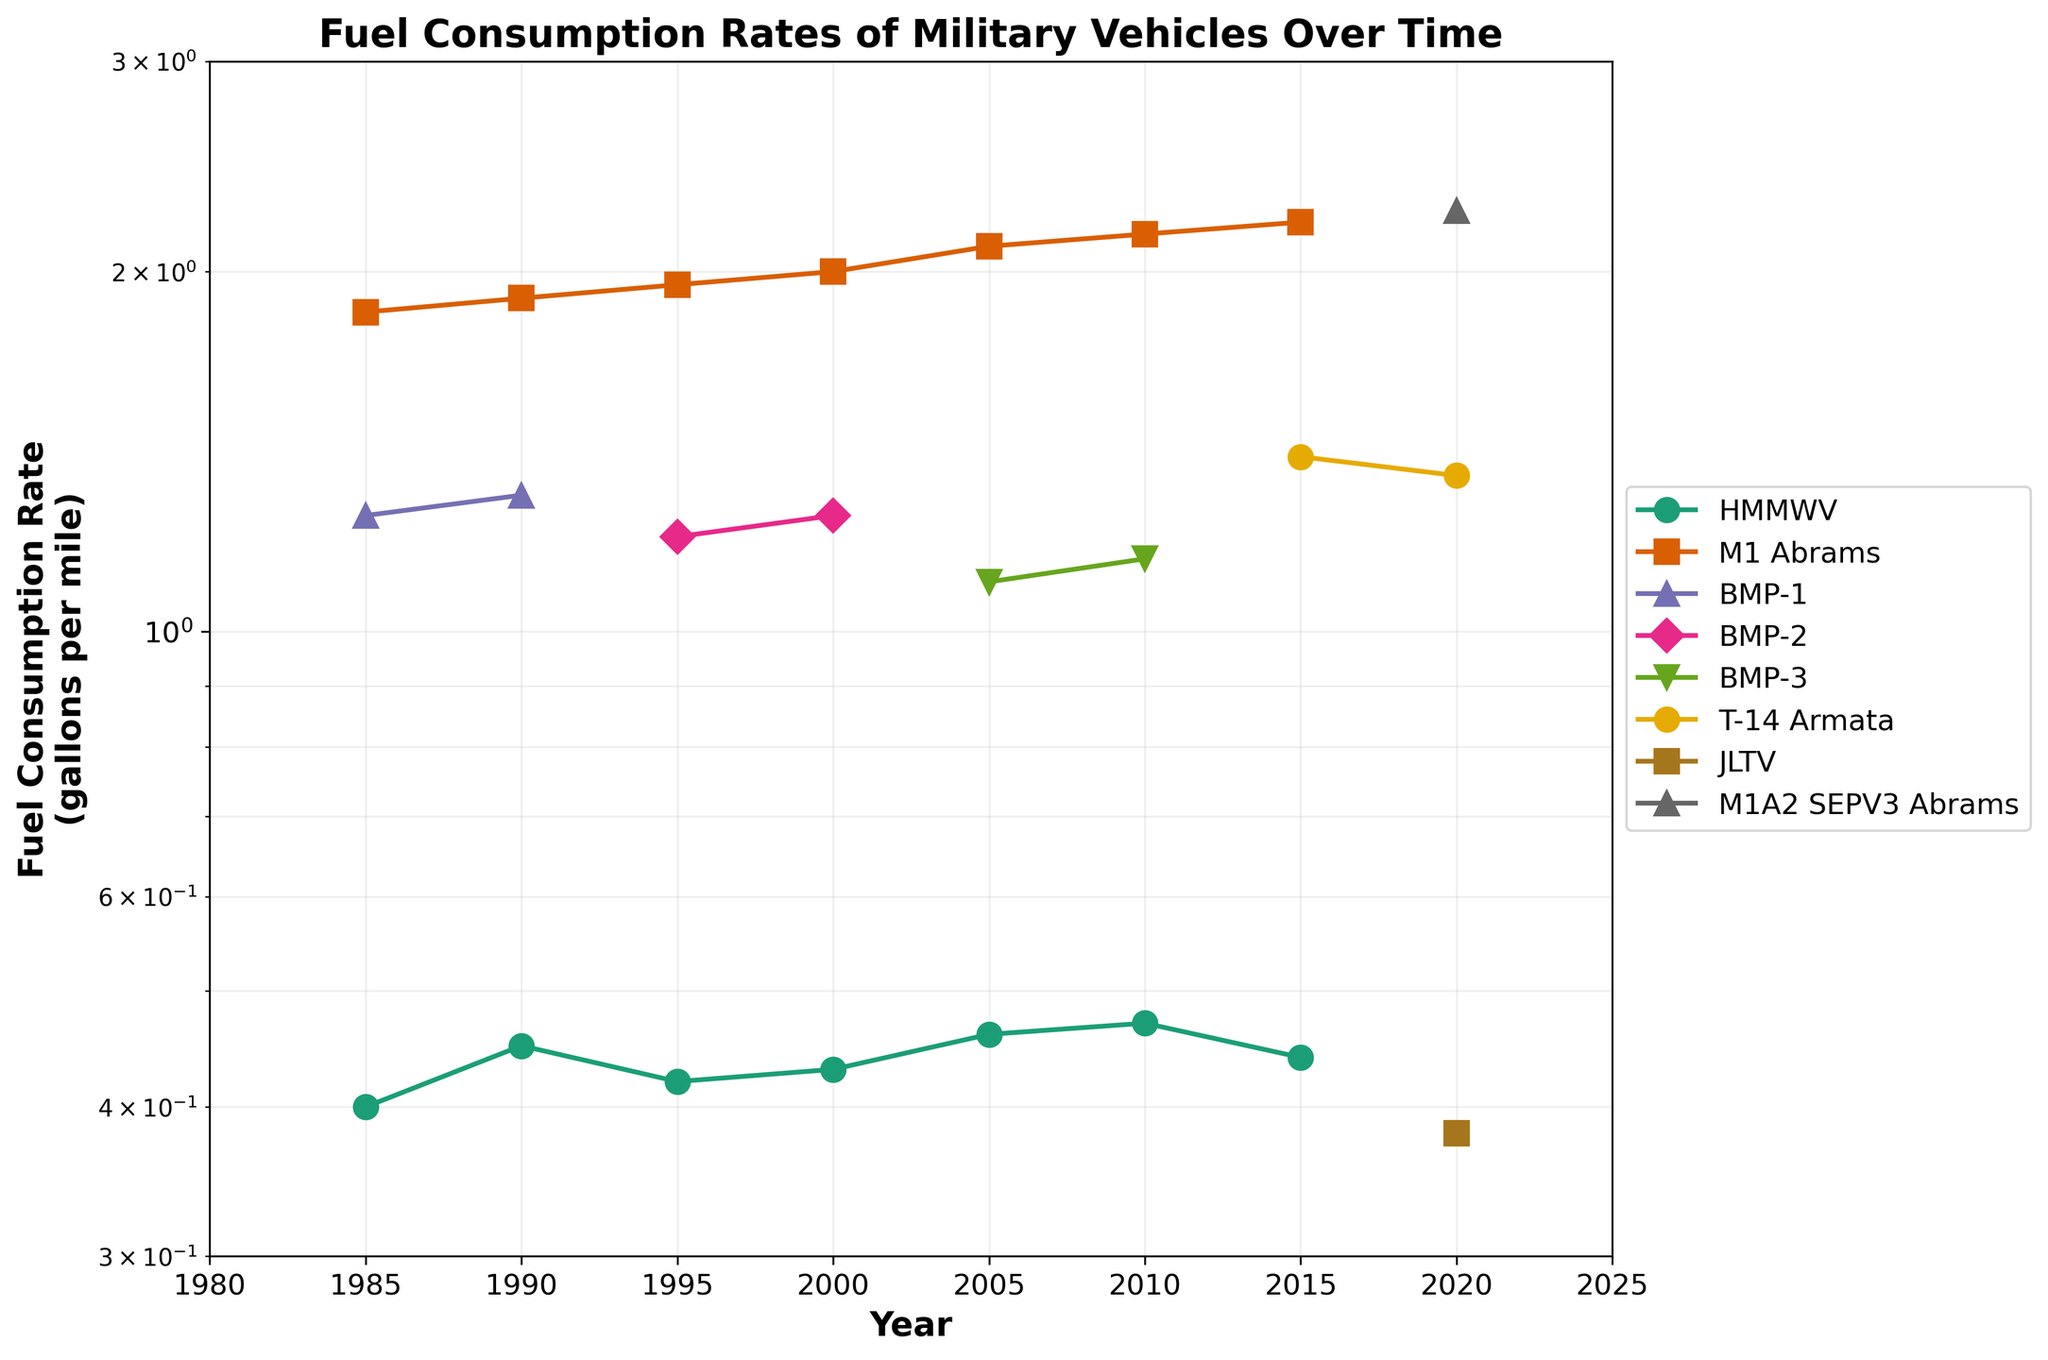What is the title of the plot? The title of the plot is located at the top. It reads "Fuel Consumption Rates of Military Vehicles Over Time".
Answer: Fuel Consumption Rates of Military Vehicles Over Time Which vehicle has the lowest fuel consumption rate in 2020? By looking at the plot's data points for the year 2020, the vehicle with the lowest y-axis value is the JLTV.
Answer: JLTV What is the y-axis label? The y-axis label provides information about the units and what is being measured. It reads "Fuel Consumption Rate (gallons per mile)".
Answer: Fuel Consumption Rate (gallons per mile) What is the general trend for HMMWV's fuel consumption rate over time? The trend for HMMWV can be seen by following its markers from left to right. It shows slight fluctuation but generally increases over the years.
Answer: Generally increases In which year did the M1 Abrams have a fuel consumption rate of 2.1 gallons per mile? By tracing the data points for M1 Abrams along the years, and identifying where it intersects with 2.1 on the y-axis, we see that this occurred in the year 2005.
Answer: 2005 Which vehicle consistently shows the highest fuel consumption rate over the years? Observing the curves, M1 Abrams and its variants have the highest vertical values in each year they are present in the data.
Answer: M1 Abrams How many vehicle types are present in the 2015 data set? To determine this, look at the unique markers/colors for the data points in the year 2015. There are three vehicle types: HMMWV, M1 Abrams, and T-14 Armata.
Answer: Three Compare the fuel consumption rate of the T-14 Armata in 2015 and 2020. The data points for T-14 Armata at 2015 and 2020 show slightly different y-axis values. In 2015 it is 1.4 gallons per mile and in 2020 it is 1.35 gallons per mile.
Answer: 1.4 gallons per mile (2015) and 1.35 gallons per mile (2020) Calculate the average fuel consumption rate of the BMP series in the years it is present. The BMP series consists of BMP-1, BMP-2, and BMP-3. Their respective fuel rates are 1.25, 1.3, 1.2, 1.25, 1.1, and 1.15 gallons per mile. Summing these values and dividing by the number of data points (6) gives (1.25 + 1.3 + 1.2 + 1.25 + 1.1 + 1.15) / 6 = 1.2083.
Answer: 1.21 gallons per mile 